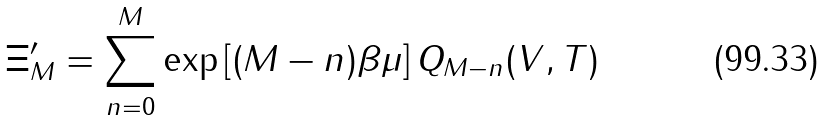<formula> <loc_0><loc_0><loc_500><loc_500>\Xi _ { M } ^ { \prime } = \sum _ { n = 0 } ^ { M } \exp \left [ ( M - n ) \beta \mu \right ] Q _ { M - n } ( V , T )</formula> 